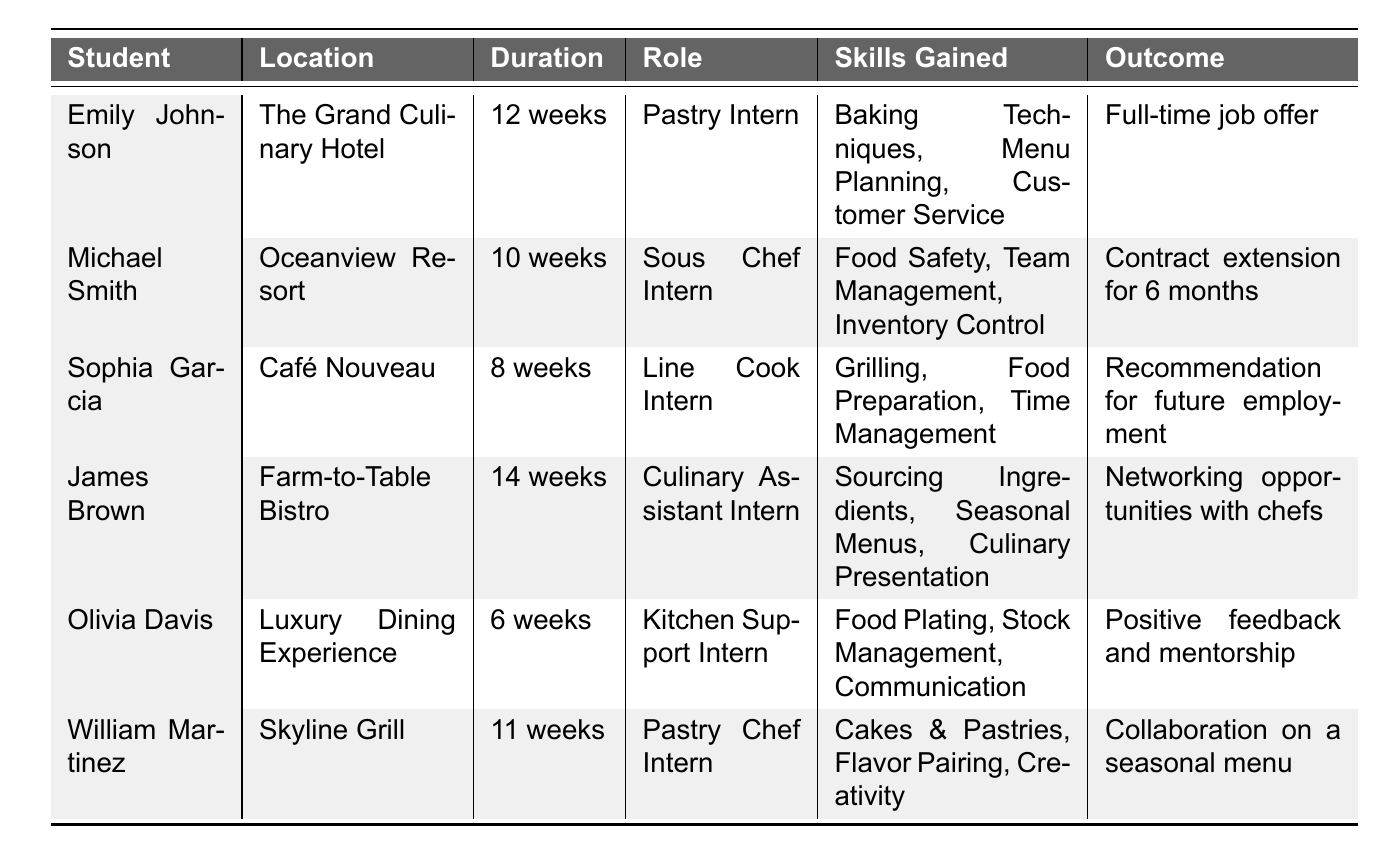What is the total duration of all internships combined? To find the total duration, I will add the durations of each internship: 12 + 10 + 8 + 14 + 6 + 11 = 61 weeks.
Answer: 61 weeks Which student had the shortest internship duration? I will look through the durations listed for each student: 12, 10, 8, 14, 6, and 11 weeks. The shortest is 6 weeks by Olivia Davis.
Answer: Olivia Davis How many students received a job offer or a contract extension after their internship? I will check the outcomes for each student. Emily Johnson received a full-time job offer, and Michael Smith got a contract extension. Therefore, 2 students received job-related outcomes.
Answer: 2 students Did any student gain skills related to pastry? I will examine the skills gained by each student. Both Emily Johnson and William Martinez have skills related to pastry: "Baking Techniques" and "Cakes & Pastries." Thus, the answer is yes.
Answer: Yes What is the average duration of the internships? I will sum the total duration as previously calculated (61 weeks) and divide it by the number of internships (6): 61/6 = 10.17.
Answer: 10.17 weeks Which internship location had the longest duration? I will look at the duration for each location: The Grand Culinary Hotel (12), Oceanview Resort (10), Café Nouveau (8), Farm-to-Table Bistro (14), Luxury Dining Experience (6), and Skyline Grill (11). Farm-to-Table Bistro has the longest at 14 weeks.
Answer: Farm-to-Table Bistro What was the most common outcome for culinary students' internships? I will check the outcomes: job offer, contract extension, recommendation, networking, positive feedback, and collaboration. No outcome is repeated, but 2 students had job-related results. However, there is no "most common" among different types.
Answer: None (no common outcome) How many different skills did the students gain related to kitchen operations? I will analyze the skills gained which include: Baking Techniques, Menu Planning, Customer Service, Food Safety, Team Management, Inventory Control, Grilling, Food Preparation, Time Management, Sourcing Ingredients, Seasonal Menus, Culinary Presentation, Food Plating, Stock Management, Communication, Cakes & Pastries, Flavor Pairing, and Creativity. The unique skills total to 17.
Answer: 17 skills 